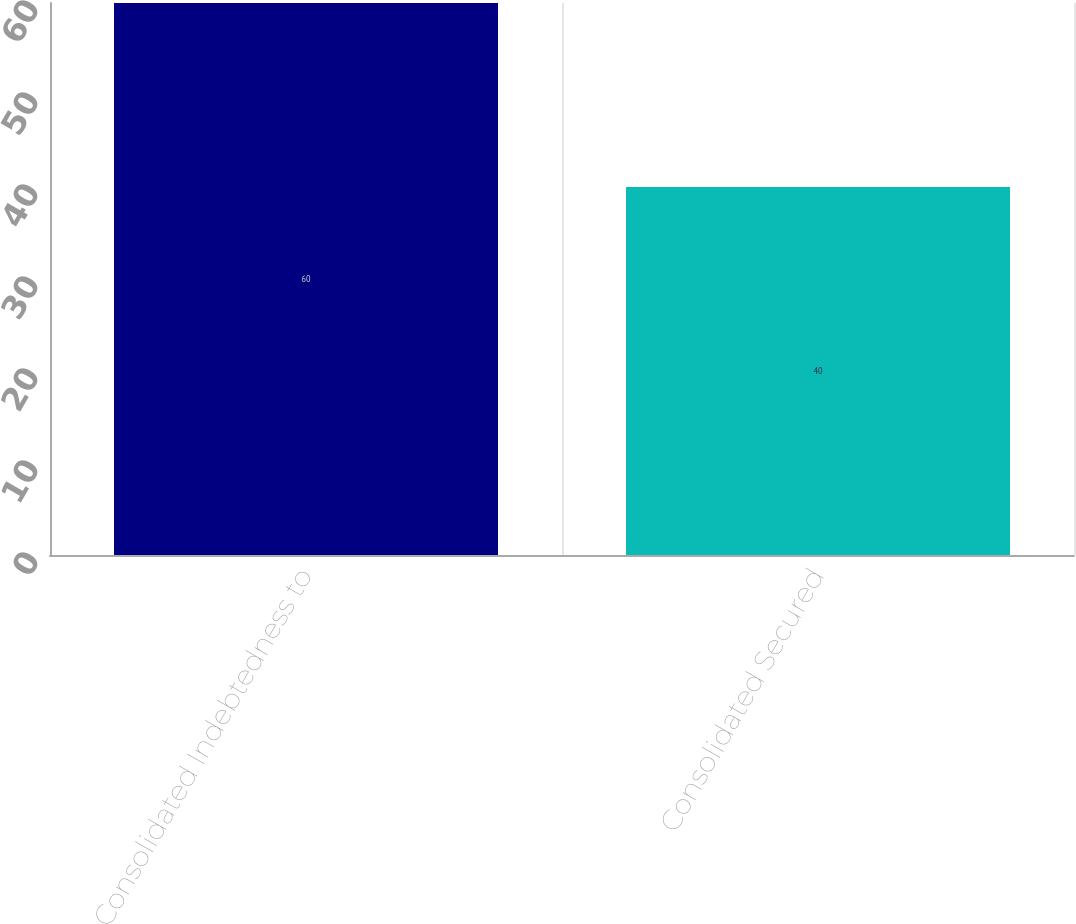<chart> <loc_0><loc_0><loc_500><loc_500><bar_chart><fcel>Consolidated Indebtedness to<fcel>Consolidated Secured<nl><fcel>60<fcel>40<nl></chart> 